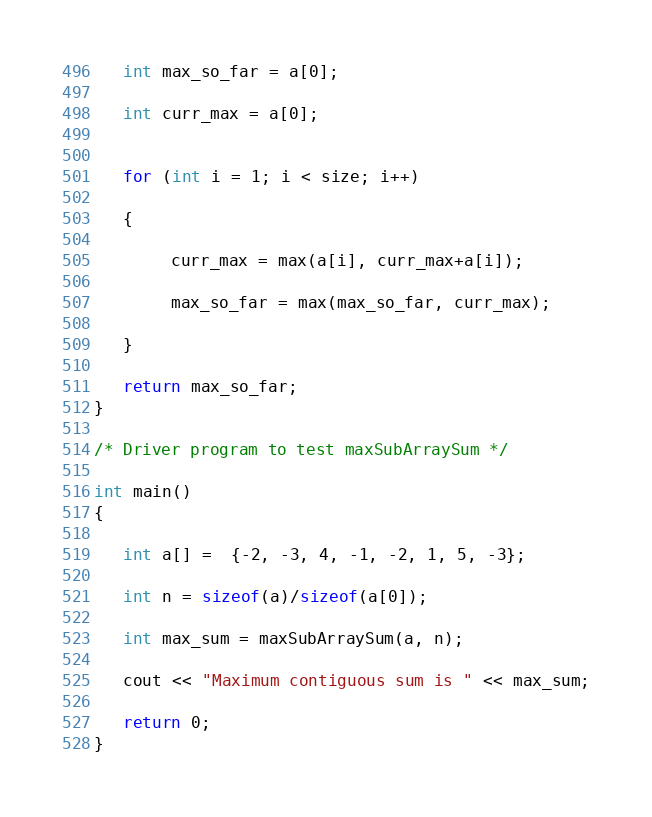<code> <loc_0><loc_0><loc_500><loc_500><_C++_>   int max_so_far = a[0];

   int curr_max = a[0];
 

   for (int i = 1; i < size; i++)

   {

        curr_max = max(a[i], curr_max+a[i]);

        max_so_far = max(max_so_far, curr_max);

   }

   return max_so_far;
}
 
/* Driver program to test maxSubArraySum */

int main()
{

   int a[] =  {-2, -3, 4, -1, -2, 1, 5, -3};

   int n = sizeof(a)/sizeof(a[0]);

   int max_sum = maxSubArraySum(a, n);

   cout << "Maximum contiguous sum is " << max_sum;

   return 0;
}
</code> 